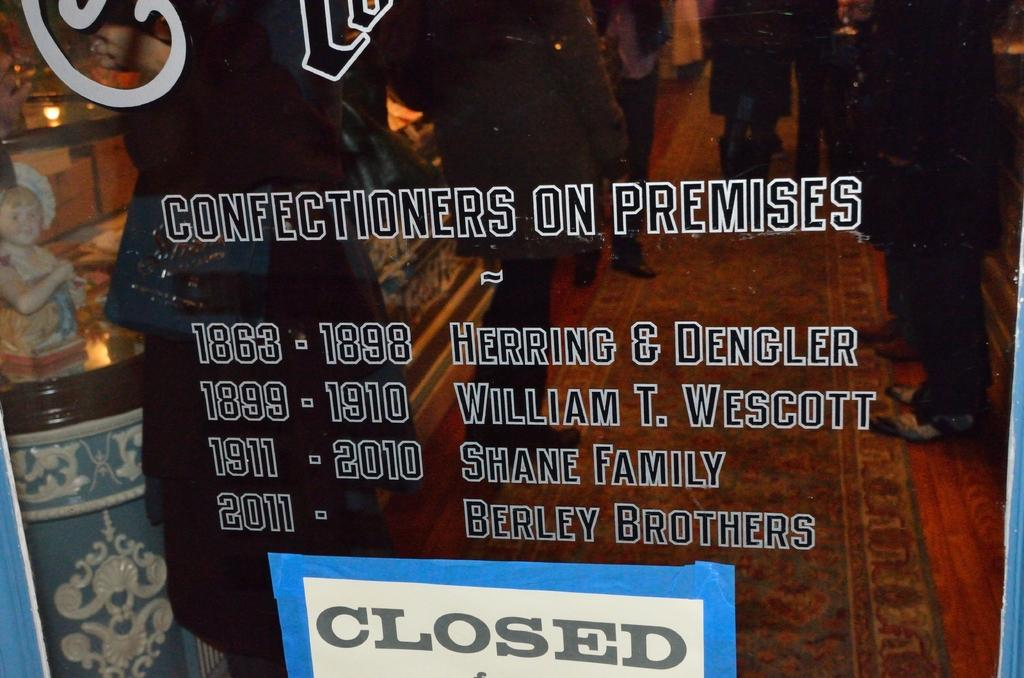What type of door is shown in the image? There is a glass door in the image. What can be seen on the glass door? There is text on the glass door, and a board is placed on it. What can be observed through the glass door? People, a carpet, toys, and lights are visible through the glass door. What type of hook is hanging from the ceiling in the image? There is no hook hanging from the ceiling in the image. What point is being made by the text on the glass door? The text on the glass door cannot be read or interpreted in the image, so it is not possible to determine the point being made. 